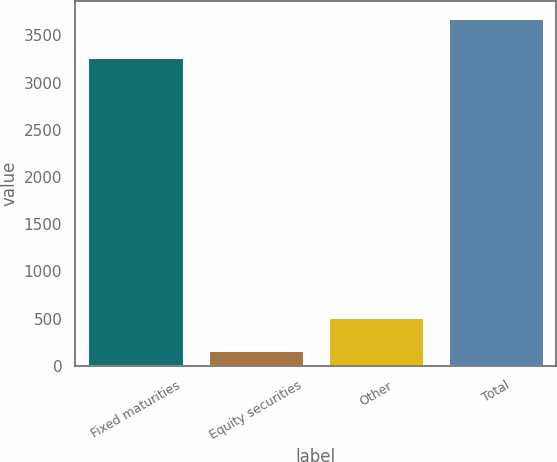Convert chart. <chart><loc_0><loc_0><loc_500><loc_500><bar_chart><fcel>Fixed maturities<fcel>Equity securities<fcel>Other<fcel>Total<nl><fcel>3274<fcel>166<fcel>517.6<fcel>3682<nl></chart> 